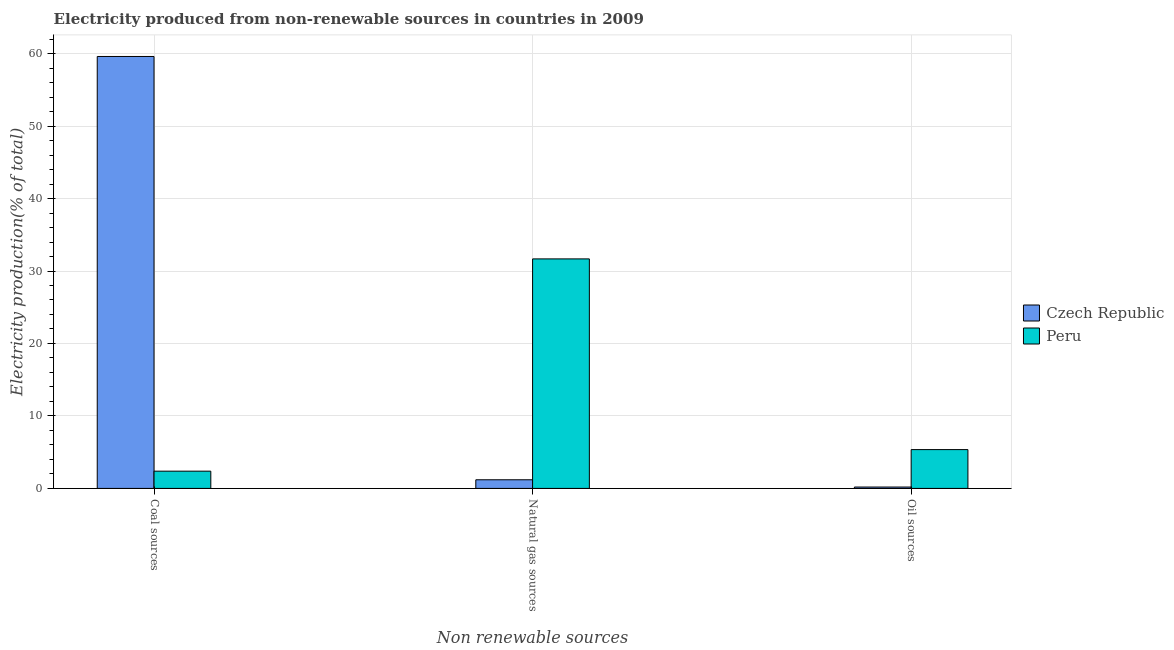How many different coloured bars are there?
Offer a very short reply. 2. How many groups of bars are there?
Offer a terse response. 3. Are the number of bars on each tick of the X-axis equal?
Offer a terse response. Yes. What is the label of the 3rd group of bars from the left?
Offer a very short reply. Oil sources. What is the percentage of electricity produced by oil sources in Czech Republic?
Keep it short and to the point. 0.19. Across all countries, what is the maximum percentage of electricity produced by coal?
Your response must be concise. 59.6. Across all countries, what is the minimum percentage of electricity produced by natural gas?
Keep it short and to the point. 1.19. What is the total percentage of electricity produced by coal in the graph?
Provide a short and direct response. 61.99. What is the difference between the percentage of electricity produced by natural gas in Czech Republic and that in Peru?
Make the answer very short. -30.48. What is the difference between the percentage of electricity produced by coal in Czech Republic and the percentage of electricity produced by natural gas in Peru?
Your answer should be very brief. 27.93. What is the average percentage of electricity produced by natural gas per country?
Provide a succinct answer. 16.43. What is the difference between the percentage of electricity produced by natural gas and percentage of electricity produced by coal in Czech Republic?
Your answer should be very brief. -58.41. In how many countries, is the percentage of electricity produced by coal greater than 52 %?
Your answer should be very brief. 1. What is the ratio of the percentage of electricity produced by natural gas in Peru to that in Czech Republic?
Provide a short and direct response. 26.54. Is the difference between the percentage of electricity produced by coal in Czech Republic and Peru greater than the difference between the percentage of electricity produced by oil sources in Czech Republic and Peru?
Make the answer very short. Yes. What is the difference between the highest and the second highest percentage of electricity produced by coal?
Offer a terse response. 57.22. What is the difference between the highest and the lowest percentage of electricity produced by oil sources?
Your answer should be very brief. 5.17. Is it the case that in every country, the sum of the percentage of electricity produced by coal and percentage of electricity produced by natural gas is greater than the percentage of electricity produced by oil sources?
Provide a short and direct response. Yes. Are all the bars in the graph horizontal?
Provide a succinct answer. No. How many countries are there in the graph?
Make the answer very short. 2. Are the values on the major ticks of Y-axis written in scientific E-notation?
Make the answer very short. No. How many legend labels are there?
Give a very brief answer. 2. What is the title of the graph?
Your response must be concise. Electricity produced from non-renewable sources in countries in 2009. What is the label or title of the X-axis?
Offer a terse response. Non renewable sources. What is the Electricity production(% of total) of Czech Republic in Coal sources?
Give a very brief answer. 59.6. What is the Electricity production(% of total) in Peru in Coal sources?
Your answer should be very brief. 2.38. What is the Electricity production(% of total) of Czech Republic in Natural gas sources?
Keep it short and to the point. 1.19. What is the Electricity production(% of total) of Peru in Natural gas sources?
Offer a terse response. 31.67. What is the Electricity production(% of total) in Czech Republic in Oil sources?
Offer a very short reply. 0.19. What is the Electricity production(% of total) in Peru in Oil sources?
Provide a succinct answer. 5.36. Across all Non renewable sources, what is the maximum Electricity production(% of total) of Czech Republic?
Keep it short and to the point. 59.6. Across all Non renewable sources, what is the maximum Electricity production(% of total) of Peru?
Offer a very short reply. 31.67. Across all Non renewable sources, what is the minimum Electricity production(% of total) in Czech Republic?
Your answer should be compact. 0.19. Across all Non renewable sources, what is the minimum Electricity production(% of total) of Peru?
Your response must be concise. 2.38. What is the total Electricity production(% of total) of Czech Republic in the graph?
Your answer should be compact. 60.99. What is the total Electricity production(% of total) in Peru in the graph?
Provide a succinct answer. 39.41. What is the difference between the Electricity production(% of total) in Czech Republic in Coal sources and that in Natural gas sources?
Make the answer very short. 58.41. What is the difference between the Electricity production(% of total) of Peru in Coal sources and that in Natural gas sources?
Provide a succinct answer. -29.29. What is the difference between the Electricity production(% of total) of Czech Republic in Coal sources and that in Oil sources?
Provide a succinct answer. 59.41. What is the difference between the Electricity production(% of total) of Peru in Coal sources and that in Oil sources?
Give a very brief answer. -2.98. What is the difference between the Electricity production(% of total) of Peru in Natural gas sources and that in Oil sources?
Your answer should be compact. 26.31. What is the difference between the Electricity production(% of total) in Czech Republic in Coal sources and the Electricity production(% of total) in Peru in Natural gas sources?
Your response must be concise. 27.93. What is the difference between the Electricity production(% of total) of Czech Republic in Coal sources and the Electricity production(% of total) of Peru in Oil sources?
Offer a very short reply. 54.25. What is the difference between the Electricity production(% of total) of Czech Republic in Natural gas sources and the Electricity production(% of total) of Peru in Oil sources?
Provide a succinct answer. -4.16. What is the average Electricity production(% of total) of Czech Republic per Non renewable sources?
Provide a succinct answer. 20.33. What is the average Electricity production(% of total) of Peru per Non renewable sources?
Provide a succinct answer. 13.14. What is the difference between the Electricity production(% of total) in Czech Republic and Electricity production(% of total) in Peru in Coal sources?
Give a very brief answer. 57.22. What is the difference between the Electricity production(% of total) in Czech Republic and Electricity production(% of total) in Peru in Natural gas sources?
Offer a very short reply. -30.48. What is the difference between the Electricity production(% of total) in Czech Republic and Electricity production(% of total) in Peru in Oil sources?
Make the answer very short. -5.17. What is the ratio of the Electricity production(% of total) in Czech Republic in Coal sources to that in Natural gas sources?
Provide a succinct answer. 49.94. What is the ratio of the Electricity production(% of total) of Peru in Coal sources to that in Natural gas sources?
Give a very brief answer. 0.08. What is the ratio of the Electricity production(% of total) of Czech Republic in Coal sources to that in Oil sources?
Offer a very short reply. 312.15. What is the ratio of the Electricity production(% of total) of Peru in Coal sources to that in Oil sources?
Provide a short and direct response. 0.44. What is the ratio of the Electricity production(% of total) of Czech Republic in Natural gas sources to that in Oil sources?
Your answer should be very brief. 6.25. What is the ratio of the Electricity production(% of total) of Peru in Natural gas sources to that in Oil sources?
Make the answer very short. 5.91. What is the difference between the highest and the second highest Electricity production(% of total) of Czech Republic?
Make the answer very short. 58.41. What is the difference between the highest and the second highest Electricity production(% of total) in Peru?
Your answer should be compact. 26.31. What is the difference between the highest and the lowest Electricity production(% of total) of Czech Republic?
Offer a terse response. 59.41. What is the difference between the highest and the lowest Electricity production(% of total) in Peru?
Your response must be concise. 29.29. 